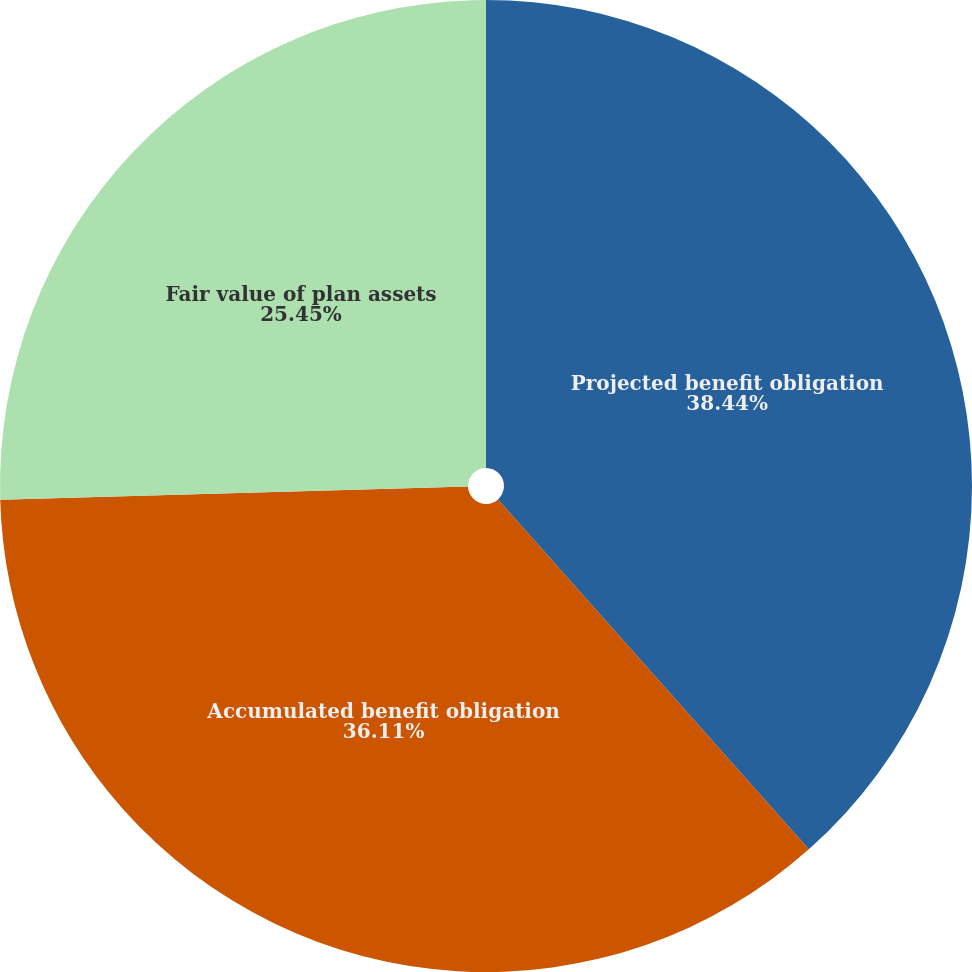Convert chart. <chart><loc_0><loc_0><loc_500><loc_500><pie_chart><fcel>Projected benefit obligation<fcel>Accumulated benefit obligation<fcel>Fair value of plan assets<nl><fcel>38.44%<fcel>36.11%<fcel>25.45%<nl></chart> 